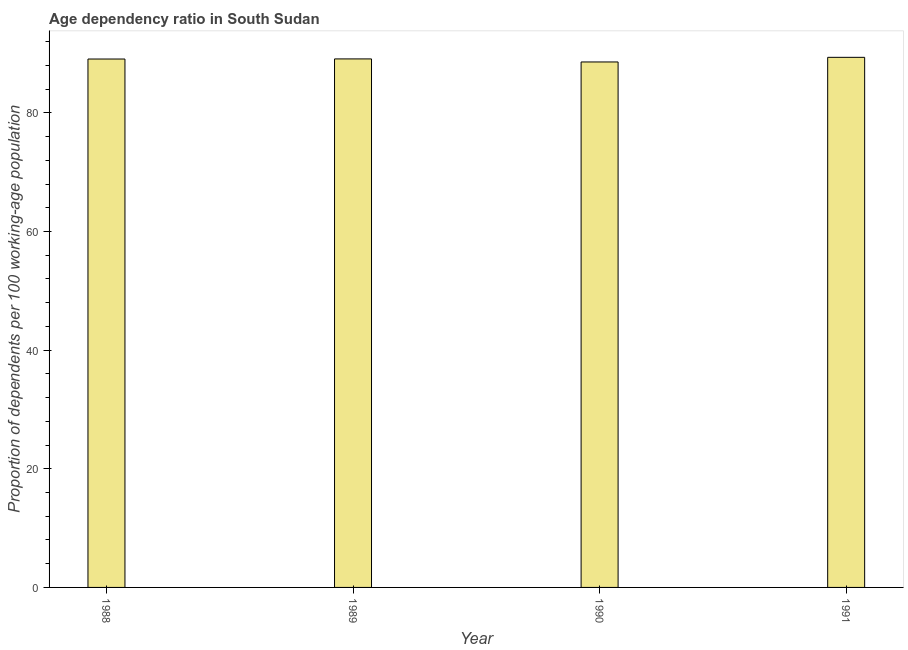Does the graph contain any zero values?
Your answer should be very brief. No. What is the title of the graph?
Give a very brief answer. Age dependency ratio in South Sudan. What is the label or title of the X-axis?
Offer a terse response. Year. What is the label or title of the Y-axis?
Ensure brevity in your answer.  Proportion of dependents per 100 working-age population. What is the age dependency ratio in 1991?
Your answer should be compact. 89.37. Across all years, what is the maximum age dependency ratio?
Give a very brief answer. 89.37. Across all years, what is the minimum age dependency ratio?
Your answer should be compact. 88.58. In which year was the age dependency ratio maximum?
Provide a succinct answer. 1991. What is the sum of the age dependency ratio?
Provide a succinct answer. 356.13. What is the difference between the age dependency ratio in 1989 and 1991?
Your answer should be very brief. -0.27. What is the average age dependency ratio per year?
Provide a short and direct response. 89.03. What is the median age dependency ratio?
Offer a terse response. 89.09. In how many years, is the age dependency ratio greater than 68 ?
Your answer should be compact. 4. What is the ratio of the age dependency ratio in 1988 to that in 1989?
Provide a short and direct response. 1. Is the age dependency ratio in 1989 less than that in 1991?
Provide a succinct answer. Yes. Is the difference between the age dependency ratio in 1989 and 1990 greater than the difference between any two years?
Ensure brevity in your answer.  No. What is the difference between the highest and the second highest age dependency ratio?
Give a very brief answer. 0.27. What is the difference between the highest and the lowest age dependency ratio?
Give a very brief answer. 0.78. Are all the bars in the graph horizontal?
Your answer should be compact. No. Are the values on the major ticks of Y-axis written in scientific E-notation?
Your answer should be very brief. No. What is the Proportion of dependents per 100 working-age population in 1988?
Your answer should be very brief. 89.08. What is the Proportion of dependents per 100 working-age population of 1989?
Offer a terse response. 89.1. What is the Proportion of dependents per 100 working-age population in 1990?
Offer a very short reply. 88.58. What is the Proportion of dependents per 100 working-age population in 1991?
Keep it short and to the point. 89.37. What is the difference between the Proportion of dependents per 100 working-age population in 1988 and 1989?
Provide a succinct answer. -0.02. What is the difference between the Proportion of dependents per 100 working-age population in 1988 and 1990?
Offer a terse response. 0.5. What is the difference between the Proportion of dependents per 100 working-age population in 1988 and 1991?
Your answer should be compact. -0.28. What is the difference between the Proportion of dependents per 100 working-age population in 1989 and 1990?
Your response must be concise. 0.51. What is the difference between the Proportion of dependents per 100 working-age population in 1989 and 1991?
Provide a short and direct response. -0.27. What is the difference between the Proportion of dependents per 100 working-age population in 1990 and 1991?
Offer a very short reply. -0.78. What is the ratio of the Proportion of dependents per 100 working-age population in 1988 to that in 1991?
Offer a terse response. 1. What is the ratio of the Proportion of dependents per 100 working-age population in 1989 to that in 1990?
Offer a terse response. 1.01. What is the ratio of the Proportion of dependents per 100 working-age population in 1989 to that in 1991?
Offer a terse response. 1. 